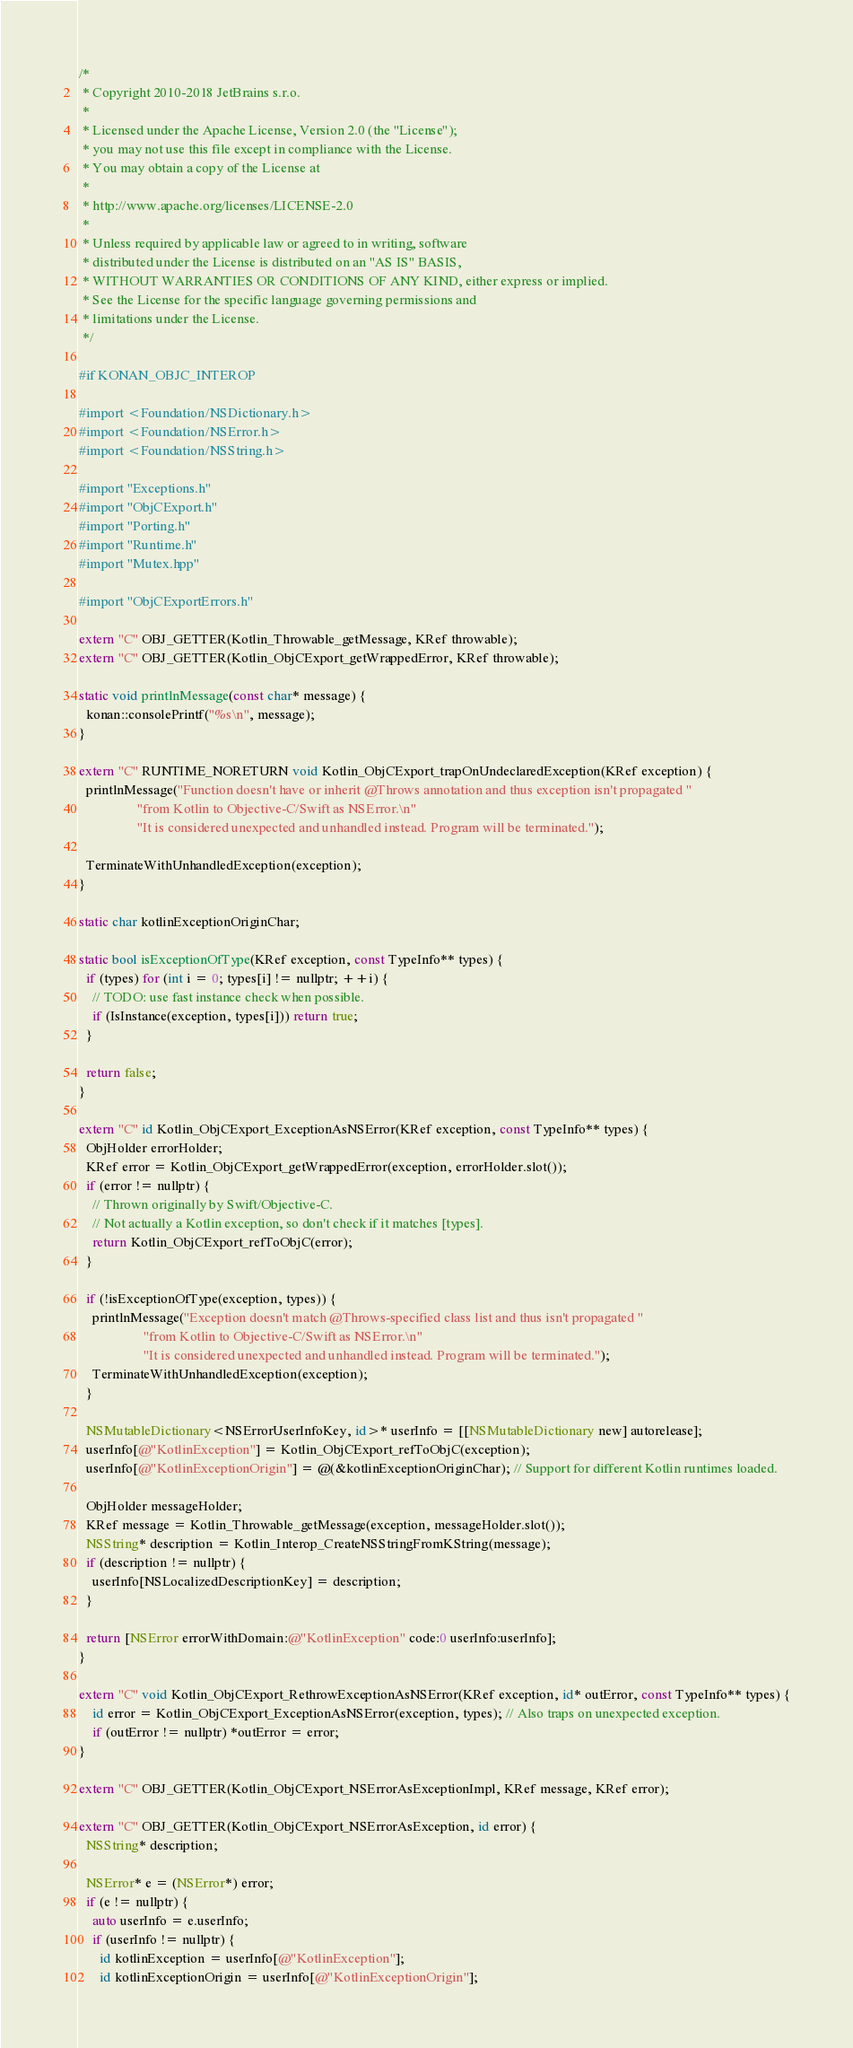<code> <loc_0><loc_0><loc_500><loc_500><_ObjectiveC_>/*
 * Copyright 2010-2018 JetBrains s.r.o.
 *
 * Licensed under the Apache License, Version 2.0 (the "License");
 * you may not use this file except in compliance with the License.
 * You may obtain a copy of the License at
 *
 * http://www.apache.org/licenses/LICENSE-2.0
 *
 * Unless required by applicable law or agreed to in writing, software
 * distributed under the License is distributed on an "AS IS" BASIS,
 * WITHOUT WARRANTIES OR CONDITIONS OF ANY KIND, either express or implied.
 * See the License for the specific language governing permissions and
 * limitations under the License.
 */

#if KONAN_OBJC_INTEROP

#import <Foundation/NSDictionary.h>
#import <Foundation/NSError.h>
#import <Foundation/NSString.h>

#import "Exceptions.h"
#import "ObjCExport.h"
#import "Porting.h"
#import "Runtime.h"
#import "Mutex.hpp"

#import "ObjCExportErrors.h"

extern "C" OBJ_GETTER(Kotlin_Throwable_getMessage, KRef throwable);
extern "C" OBJ_GETTER(Kotlin_ObjCExport_getWrappedError, KRef throwable);

static void printlnMessage(const char* message) {
  konan::consolePrintf("%s\n", message);
}

extern "C" RUNTIME_NORETURN void Kotlin_ObjCExport_trapOnUndeclaredException(KRef exception) {
  printlnMessage("Function doesn't have or inherit @Throws annotation and thus exception isn't propagated "
                 "from Kotlin to Objective-C/Swift as NSError.\n"
                 "It is considered unexpected and unhandled instead. Program will be terminated.");

  TerminateWithUnhandledException(exception);
}

static char kotlinExceptionOriginChar;

static bool isExceptionOfType(KRef exception, const TypeInfo** types) {
  if (types) for (int i = 0; types[i] != nullptr; ++i) {
    // TODO: use fast instance check when possible.
    if (IsInstance(exception, types[i])) return true;
  }

  return false;
}

extern "C" id Kotlin_ObjCExport_ExceptionAsNSError(KRef exception, const TypeInfo** types) {
  ObjHolder errorHolder;
  KRef error = Kotlin_ObjCExport_getWrappedError(exception, errorHolder.slot());
  if (error != nullptr) {
    // Thrown originally by Swift/Objective-C.
    // Not actually a Kotlin exception, so don't check if it matches [types].
    return Kotlin_ObjCExport_refToObjC(error);
  }

  if (!isExceptionOfType(exception, types)) {
    printlnMessage("Exception doesn't match @Throws-specified class list and thus isn't propagated "
                   "from Kotlin to Objective-C/Swift as NSError.\n"
                   "It is considered unexpected and unhandled instead. Program will be terminated.");
    TerminateWithUnhandledException(exception);
  }

  NSMutableDictionary<NSErrorUserInfoKey, id>* userInfo = [[NSMutableDictionary new] autorelease];
  userInfo[@"KotlinException"] = Kotlin_ObjCExport_refToObjC(exception);
  userInfo[@"KotlinExceptionOrigin"] = @(&kotlinExceptionOriginChar); // Support for different Kotlin runtimes loaded.

  ObjHolder messageHolder;
  KRef message = Kotlin_Throwable_getMessage(exception, messageHolder.slot());
  NSString* description = Kotlin_Interop_CreateNSStringFromKString(message);
  if (description != nullptr) {
    userInfo[NSLocalizedDescriptionKey] = description;
  }

  return [NSError errorWithDomain:@"KotlinException" code:0 userInfo:userInfo];
}

extern "C" void Kotlin_ObjCExport_RethrowExceptionAsNSError(KRef exception, id* outError, const TypeInfo** types) {
    id error = Kotlin_ObjCExport_ExceptionAsNSError(exception, types); // Also traps on unexpected exception.
    if (outError != nullptr) *outError = error;
}

extern "C" OBJ_GETTER(Kotlin_ObjCExport_NSErrorAsExceptionImpl, KRef message, KRef error);

extern "C" OBJ_GETTER(Kotlin_ObjCExport_NSErrorAsException, id error) {
  NSString* description;

  NSError* e = (NSError*) error;
  if (e != nullptr) {
    auto userInfo = e.userInfo;
    if (userInfo != nullptr) {
      id kotlinException = userInfo[@"KotlinException"];
      id kotlinExceptionOrigin = userInfo[@"KotlinExceptionOrigin"];</code> 